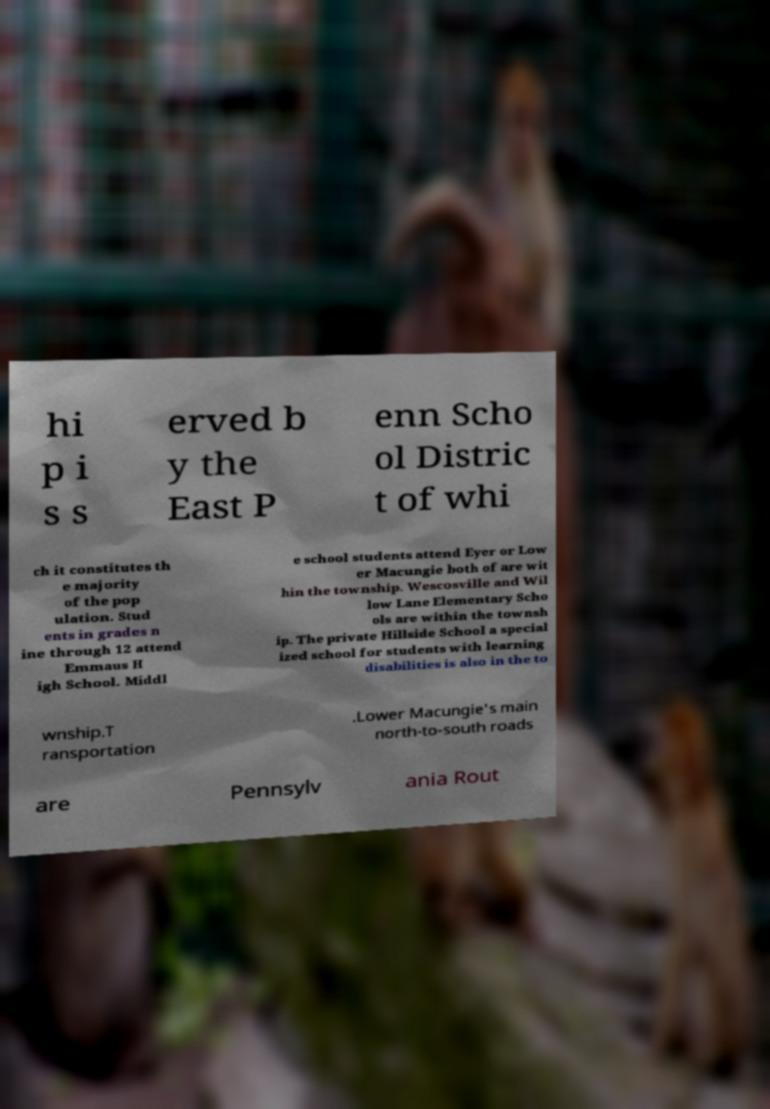Please identify and transcribe the text found in this image. hi p i s s erved b y the East P enn Scho ol Distric t of whi ch it constitutes th e majority of the pop ulation. Stud ents in grades n ine through 12 attend Emmaus H igh School. Middl e school students attend Eyer or Low er Macungie both of are wit hin the township. Wescosville and Wil low Lane Elementary Scho ols are within the townsh ip. The private Hillside School a special ized school for students with learning disabilities is also in the to wnship.T ransportation .Lower Macungie's main north-to-south roads are Pennsylv ania Rout 